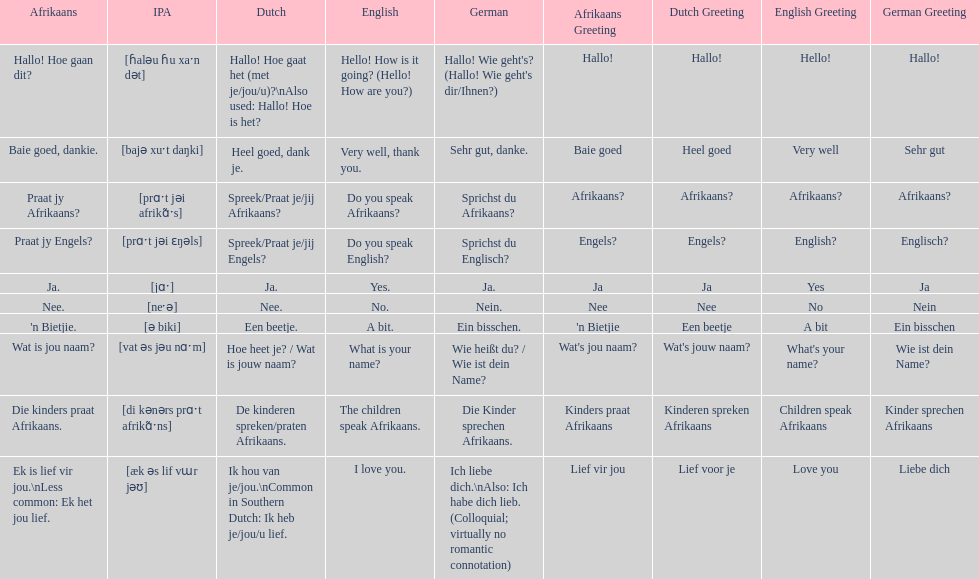How do you say 'do you speak afrikaans?' in afrikaans? Praat jy Afrikaans?. 